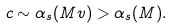<formula> <loc_0><loc_0><loc_500><loc_500>c \sim \alpha _ { s } ( M v ) > \alpha _ { s } ( M ) .</formula> 